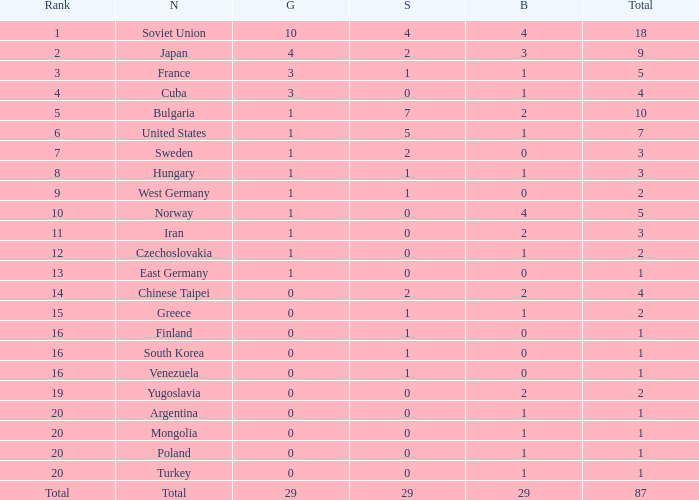Which rank has 1 silver medal and more than 1 gold medal? 3.0. 